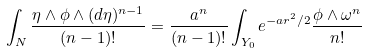Convert formula to latex. <formula><loc_0><loc_0><loc_500><loc_500>\int _ { N } \frac { \eta \wedge \phi \wedge ( d \eta ) ^ { n - 1 } } { ( n - 1 ) ! } = \frac { a ^ { n } } { ( n - 1 ) ! } \int _ { Y _ { 0 } } e ^ { - a r ^ { 2 } / 2 } \frac { \phi \wedge \omega ^ { n } } { n ! }</formula> 